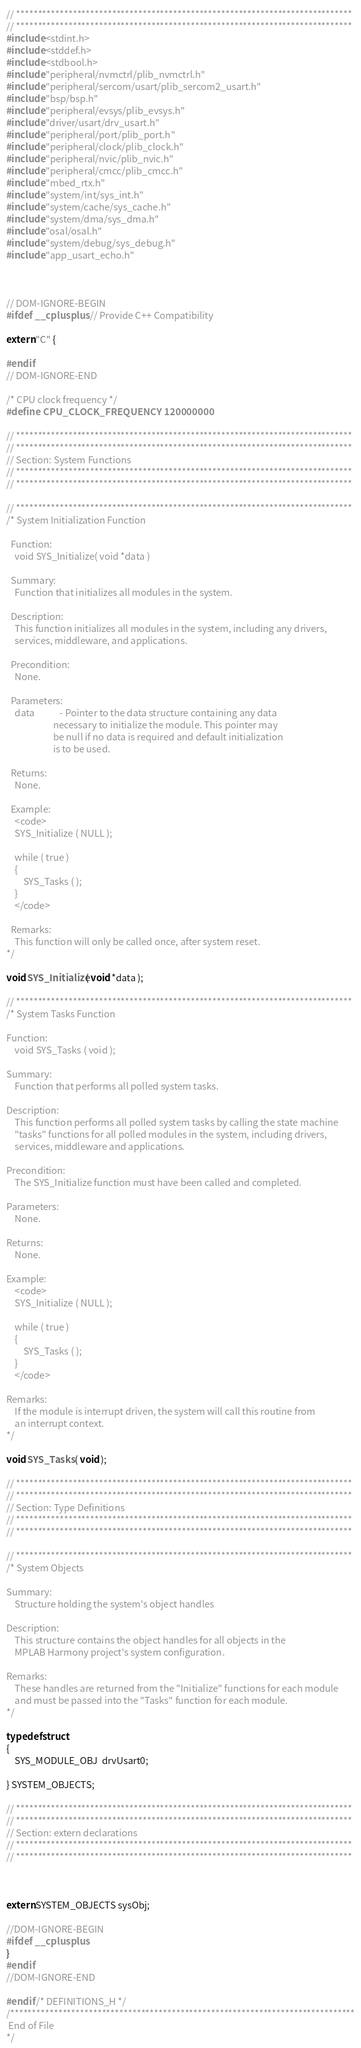<code> <loc_0><loc_0><loc_500><loc_500><_C_>// *****************************************************************************
// *****************************************************************************
#include <stdint.h>
#include <stddef.h>
#include <stdbool.h>
#include "peripheral/nvmctrl/plib_nvmctrl.h"
#include "peripheral/sercom/usart/plib_sercom2_usart.h"
#include "bsp/bsp.h"
#include "peripheral/evsys/plib_evsys.h"
#include "driver/usart/drv_usart.h"
#include "peripheral/port/plib_port.h"
#include "peripheral/clock/plib_clock.h"
#include "peripheral/nvic/plib_nvic.h"
#include "peripheral/cmcc/plib_cmcc.h"
#include "mbed_rtx.h"
#include "system/int/sys_int.h"
#include "system/cache/sys_cache.h"
#include "system/dma/sys_dma.h"
#include "osal/osal.h"
#include "system/debug/sys_debug.h"
#include "app_usart_echo.h"



// DOM-IGNORE-BEGIN
#ifdef __cplusplus  // Provide C++ Compatibility

extern "C" {

#endif
// DOM-IGNORE-END

/* CPU clock frequency */
#define CPU_CLOCK_FREQUENCY 120000000

// *****************************************************************************
// *****************************************************************************
// Section: System Functions
// *****************************************************************************
// *****************************************************************************

// *****************************************************************************
/* System Initialization Function

  Function:
    void SYS_Initialize( void *data )

  Summary:
    Function that initializes all modules in the system.

  Description:
    This function initializes all modules in the system, including any drivers,
    services, middleware, and applications.

  Precondition:
    None.

  Parameters:
    data            - Pointer to the data structure containing any data
                      necessary to initialize the module. This pointer may
                      be null if no data is required and default initialization
                      is to be used.

  Returns:
    None.

  Example:
    <code>
    SYS_Initialize ( NULL );

    while ( true )
    {
        SYS_Tasks ( );
    }
    </code>

  Remarks:
    This function will only be called once, after system reset.
*/

void SYS_Initialize( void *data );

// *****************************************************************************
/* System Tasks Function

Function:
    void SYS_Tasks ( void );

Summary:
    Function that performs all polled system tasks.

Description:
    This function performs all polled system tasks by calling the state machine
    "tasks" functions for all polled modules in the system, including drivers,
    services, middleware and applications.

Precondition:
    The SYS_Initialize function must have been called and completed.

Parameters:
    None.

Returns:
    None.

Example:
    <code>
    SYS_Initialize ( NULL );

    while ( true )
    {
        SYS_Tasks ( );
    }
    </code>

Remarks:
    If the module is interrupt driven, the system will call this routine from
    an interrupt context.
*/

void SYS_Tasks ( void );

// *****************************************************************************
// *****************************************************************************
// Section: Type Definitions
// *****************************************************************************
// *****************************************************************************

// *****************************************************************************
/* System Objects

Summary:
    Structure holding the system's object handles

Description:
    This structure contains the object handles for all objects in the
    MPLAB Harmony project's system configuration.

Remarks:
    These handles are returned from the "Initialize" functions for each module
    and must be passed into the "Tasks" function for each module.
*/

typedef struct
{
    SYS_MODULE_OBJ  drvUsart0;

} SYSTEM_OBJECTS;

// *****************************************************************************
// *****************************************************************************
// Section: extern declarations
// *****************************************************************************
// *****************************************************************************



extern SYSTEM_OBJECTS sysObj;

//DOM-IGNORE-BEGIN
#ifdef __cplusplus
}
#endif
//DOM-IGNORE-END

#endif /* DEFINITIONS_H */
/*******************************************************************************
 End of File
*/

</code> 